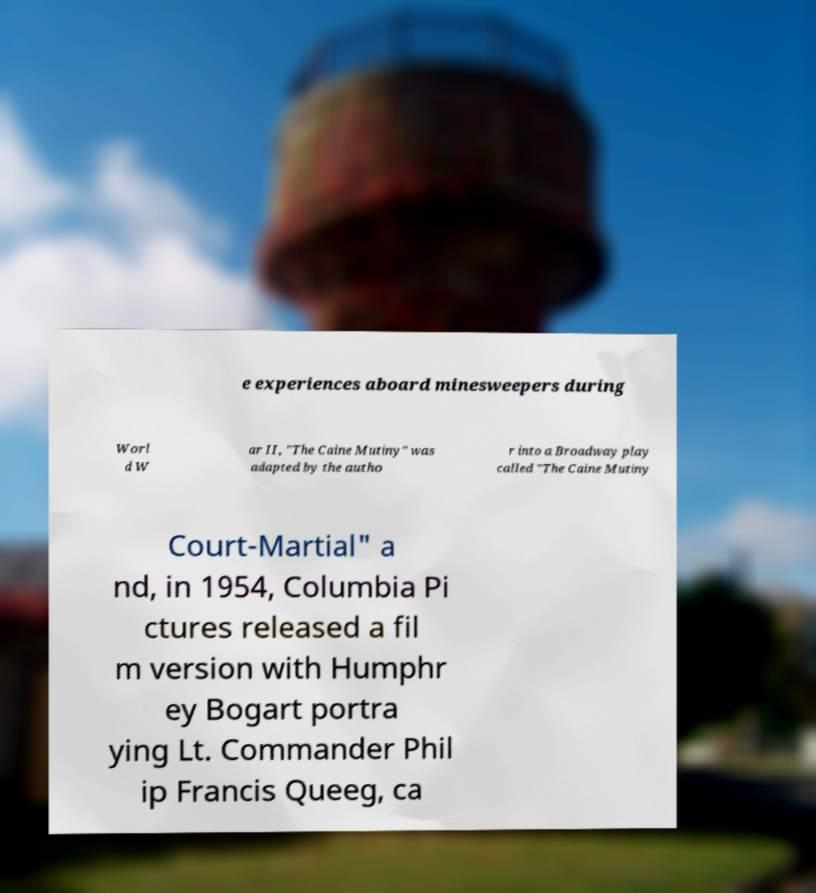What messages or text are displayed in this image? I need them in a readable, typed format. e experiences aboard minesweepers during Worl d W ar II, "The Caine Mutiny" was adapted by the autho r into a Broadway play called "The Caine Mutiny Court-Martial" a nd, in 1954, Columbia Pi ctures released a fil m version with Humphr ey Bogart portra ying Lt. Commander Phil ip Francis Queeg, ca 